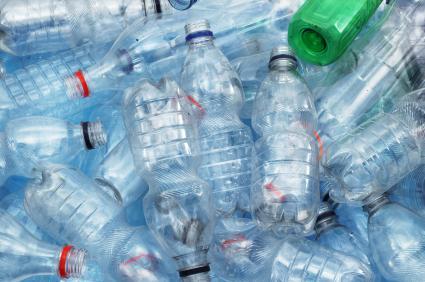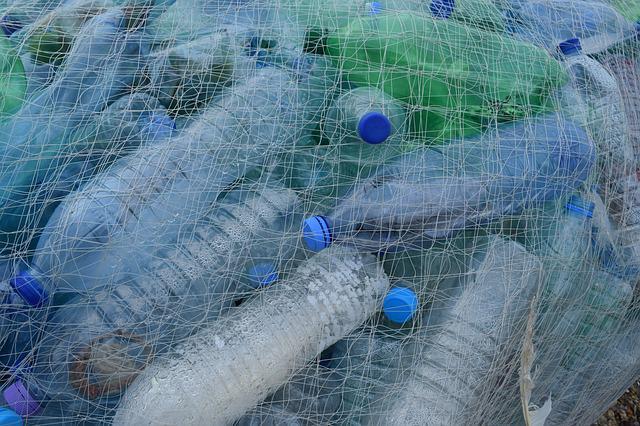The first image is the image on the left, the second image is the image on the right. Assess this claim about the two images: "There is a variety of bottle in one of the images.". Correct or not? Answer yes or no. Yes. 